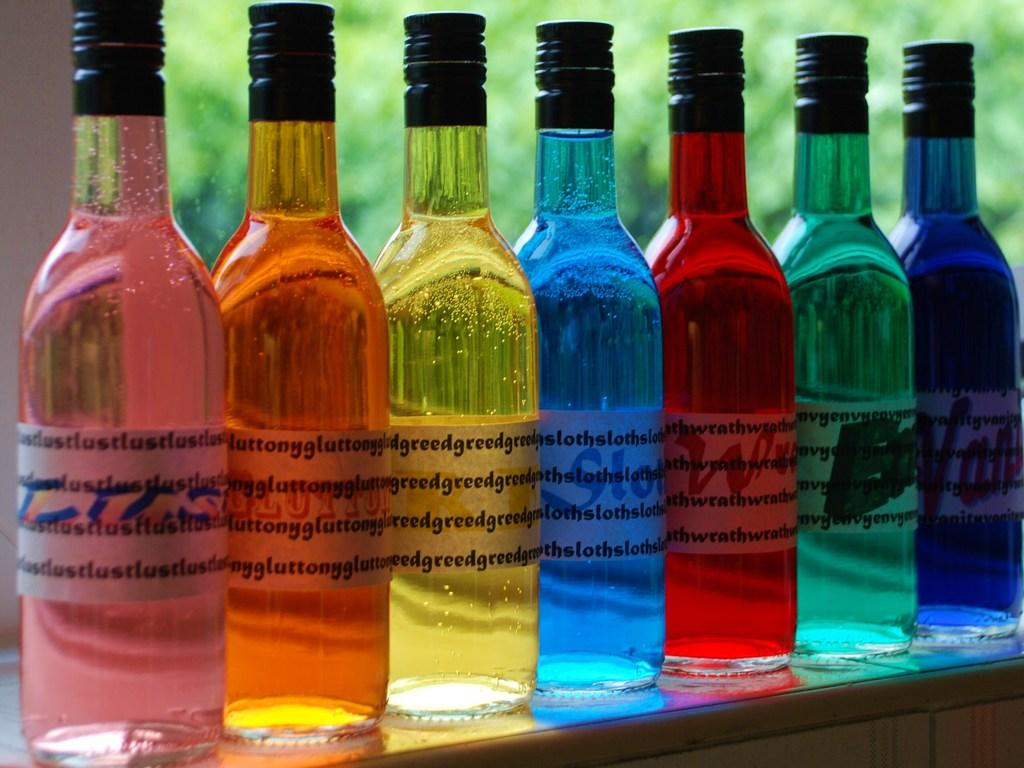What objects can be seen in the image? There are bottles in the image. What can be seen in the distance in the image? There are trees in the background of the image. What type of jewel is hidden in the button of the image? There is no button or jewel present in the image; it only features bottles and trees in the background. 